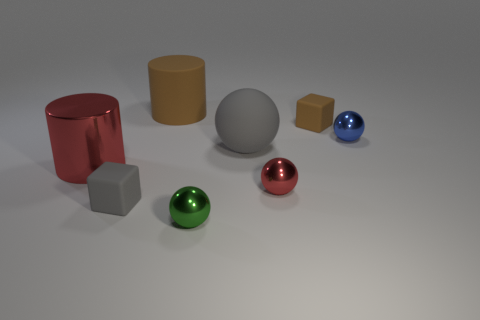Subtract all cylinders. How many objects are left? 6 Add 2 red spheres. How many objects exist? 10 Subtract all tiny blue balls. How many balls are left? 3 Subtract all blue balls. Subtract all cyan cylinders. How many balls are left? 3 Subtract all green blocks. How many brown spheres are left? 0 Subtract all tiny matte cubes. Subtract all large red metallic cylinders. How many objects are left? 5 Add 2 tiny shiny spheres. How many tiny shiny spheres are left? 5 Add 5 large cyan matte cylinders. How many large cyan matte cylinders exist? 5 Subtract all red balls. How many balls are left? 3 Subtract 0 purple cubes. How many objects are left? 8 